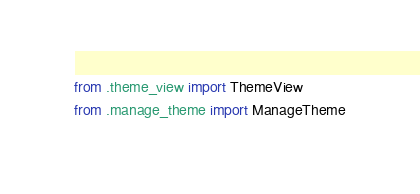<code> <loc_0><loc_0><loc_500><loc_500><_Python_>from .theme_view import ThemeView
from .manage_theme import ManageTheme</code> 